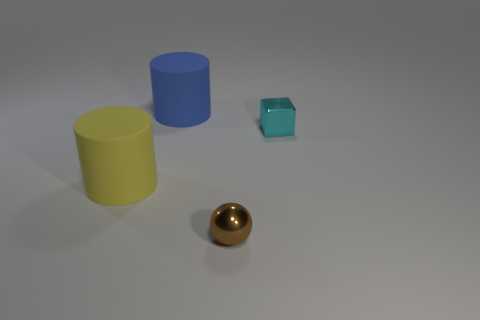There is another big thing that is the same shape as the large yellow thing; what is its material?
Provide a short and direct response. Rubber. What is the shape of the thing to the right of the ball?
Offer a terse response. Cube. Are there any cyan things that have the same material as the brown sphere?
Your answer should be compact. Yes. Do the yellow cylinder and the block have the same size?
Your answer should be compact. No. How many cylinders are brown shiny objects or big blue objects?
Provide a succinct answer. 1. How many other large matte things have the same shape as the blue rubber object?
Offer a terse response. 1. Are there more large matte things that are behind the cyan cube than large matte things in front of the yellow rubber thing?
Your response must be concise. Yes. There is a tiny thing that is behind the tiny ball; does it have the same color as the sphere?
Your answer should be compact. No. The blue rubber cylinder has what size?
Make the answer very short. Large. There is a thing that is the same size as the yellow cylinder; what is its material?
Your response must be concise. Rubber. 